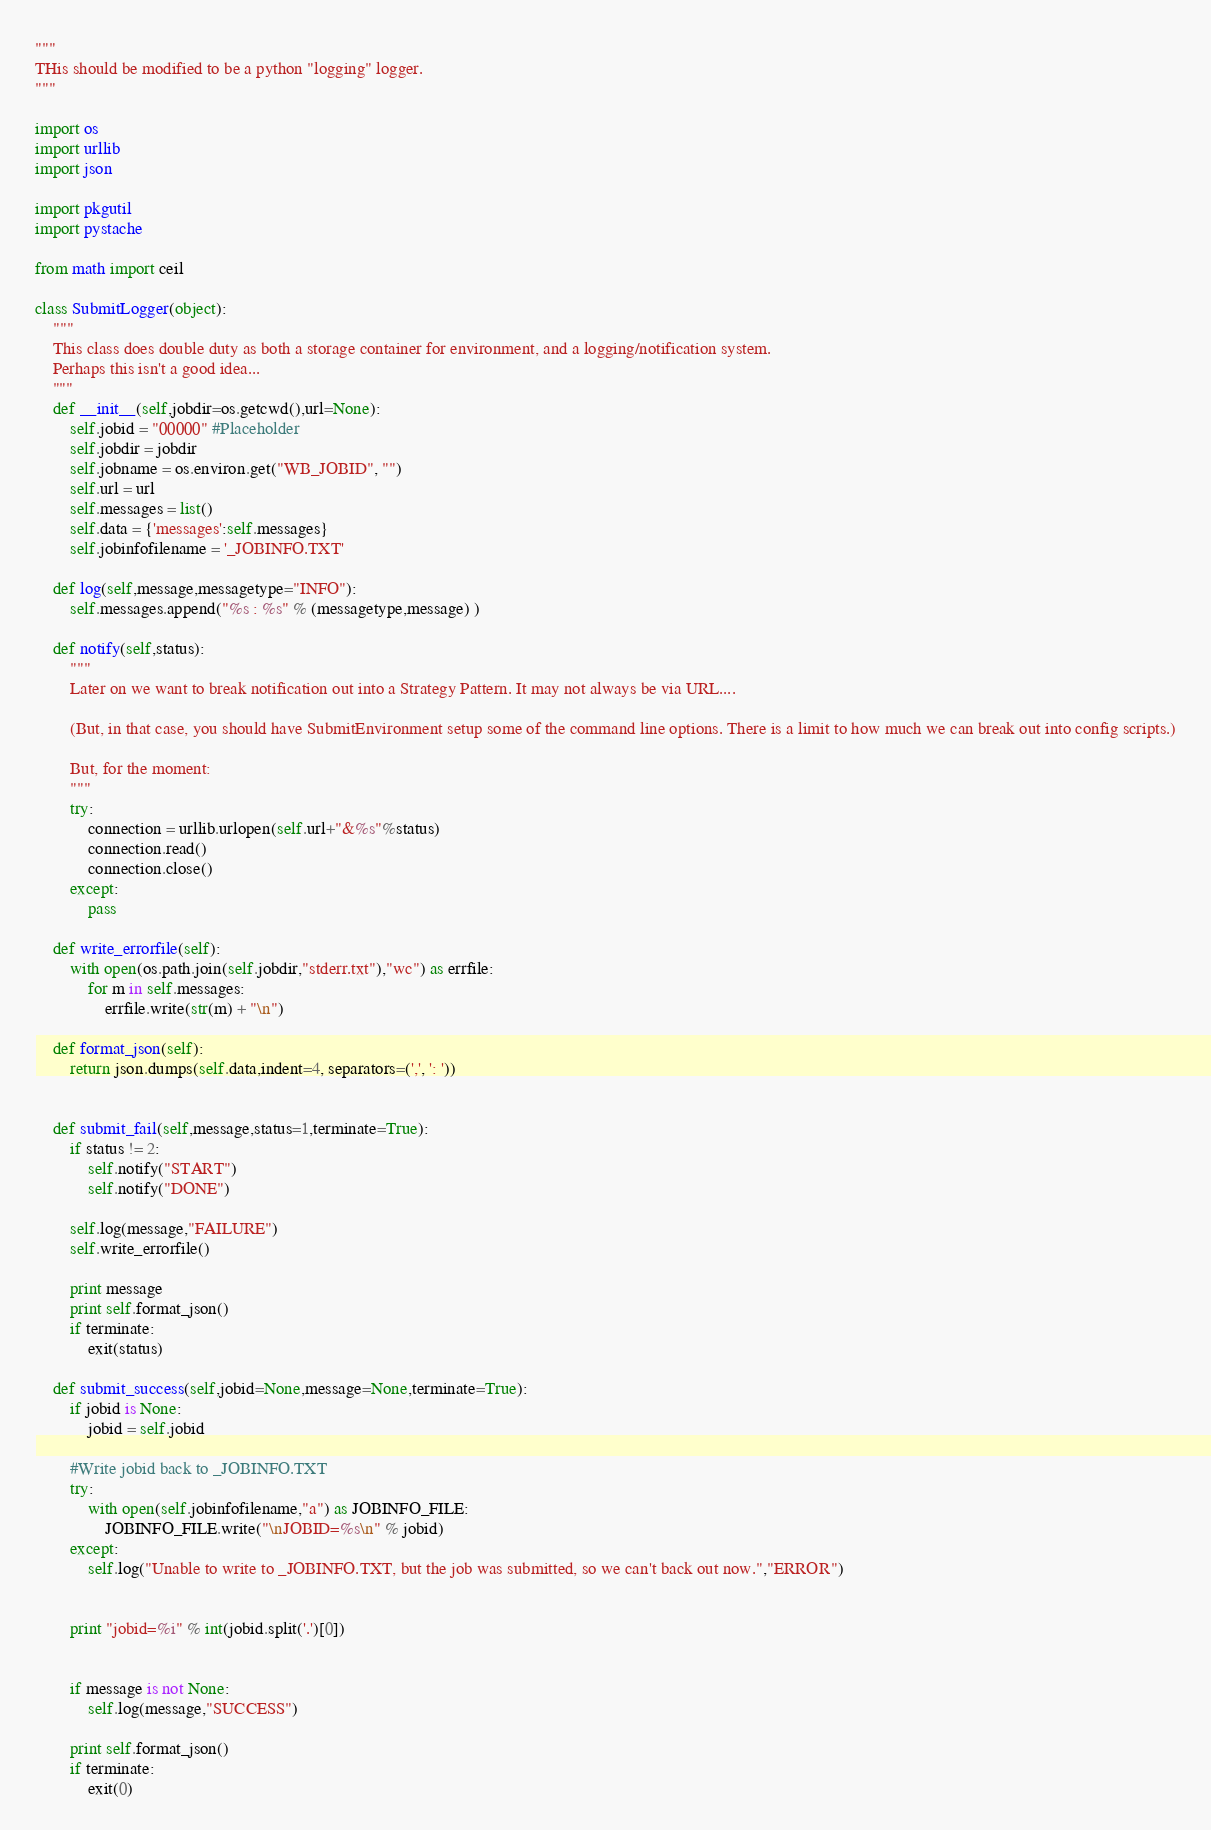<code> <loc_0><loc_0><loc_500><loc_500><_Python_>"""
THis should be modified to be a python "logging" logger.
"""

import os
import urllib
import json

import pkgutil
import pystache

from math import ceil

class SubmitLogger(object):
	"""
	This class does double duty as both a storage container for environment, and a logging/notification system.
	Perhaps this isn't a good idea...
	"""
	def __init__(self,jobdir=os.getcwd(),url=None):
		self.jobid = "00000" #Placeholder
		self.jobdir = jobdir
		self.jobname = os.environ.get("WB_JOBID", "")
		self.url = url
		self.messages = list()
		self.data = {'messages':self.messages}
		self.jobinfofilename = '_JOBINFO.TXT'

	def log(self,message,messagetype="INFO"):
		self.messages.append("%s : %s" % (messagetype,message) )

	def notify(self,status):
		"""
		Later on we want to break notification out into a Strategy Pattern. It may not always be via URL....
		
		(But, in that case, you should have SubmitEnvironment setup some of the command line options. There is a limit to how much we can break out into config scripts.)
		
		But, for the moment:
		"""
		try:
			connection = urllib.urlopen(self.url+"&%s"%status)
			connection.read()
			connection.close()
		except:
			pass

	def write_errorfile(self):
		with open(os.path.join(self.jobdir,"stderr.txt"),"wc") as errfile:
			for m in self.messages:
				errfile.write(str(m) + "\n")

	def format_json(self):
		return json.dumps(self.data,indent=4, separators=(',', ': '))
	

	def submit_fail(self,message,status=1,terminate=True):
		if status != 2:
			self.notify("START")
			self.notify("DONE")
		
		self.log(message,"FAILURE")
		self.write_errorfile()

		print message
		print self.format_json()
		if terminate:
			exit(status)

	def submit_success(self,jobid=None,message=None,terminate=True):
		if jobid is None:
			jobid = self.jobid
		
		#Write jobid back to _JOBINFO.TXT
		try: 
			with open(self.jobinfofilename,"a") as JOBINFO_FILE:
				JOBINFO_FILE.write("\nJOBID=%s\n" % jobid)
		except:
			self.log("Unable to write to _JOBINFO.TXT, but the job was submitted, so we can't back out now.","ERROR")
		
		
		print "jobid=%i" % int(jobid.split('.')[0])
		
		
		if message is not None:
			self.log(message,"SUCCESS")
		
		print self.format_json()
		if terminate:
			exit(0)
</code> 